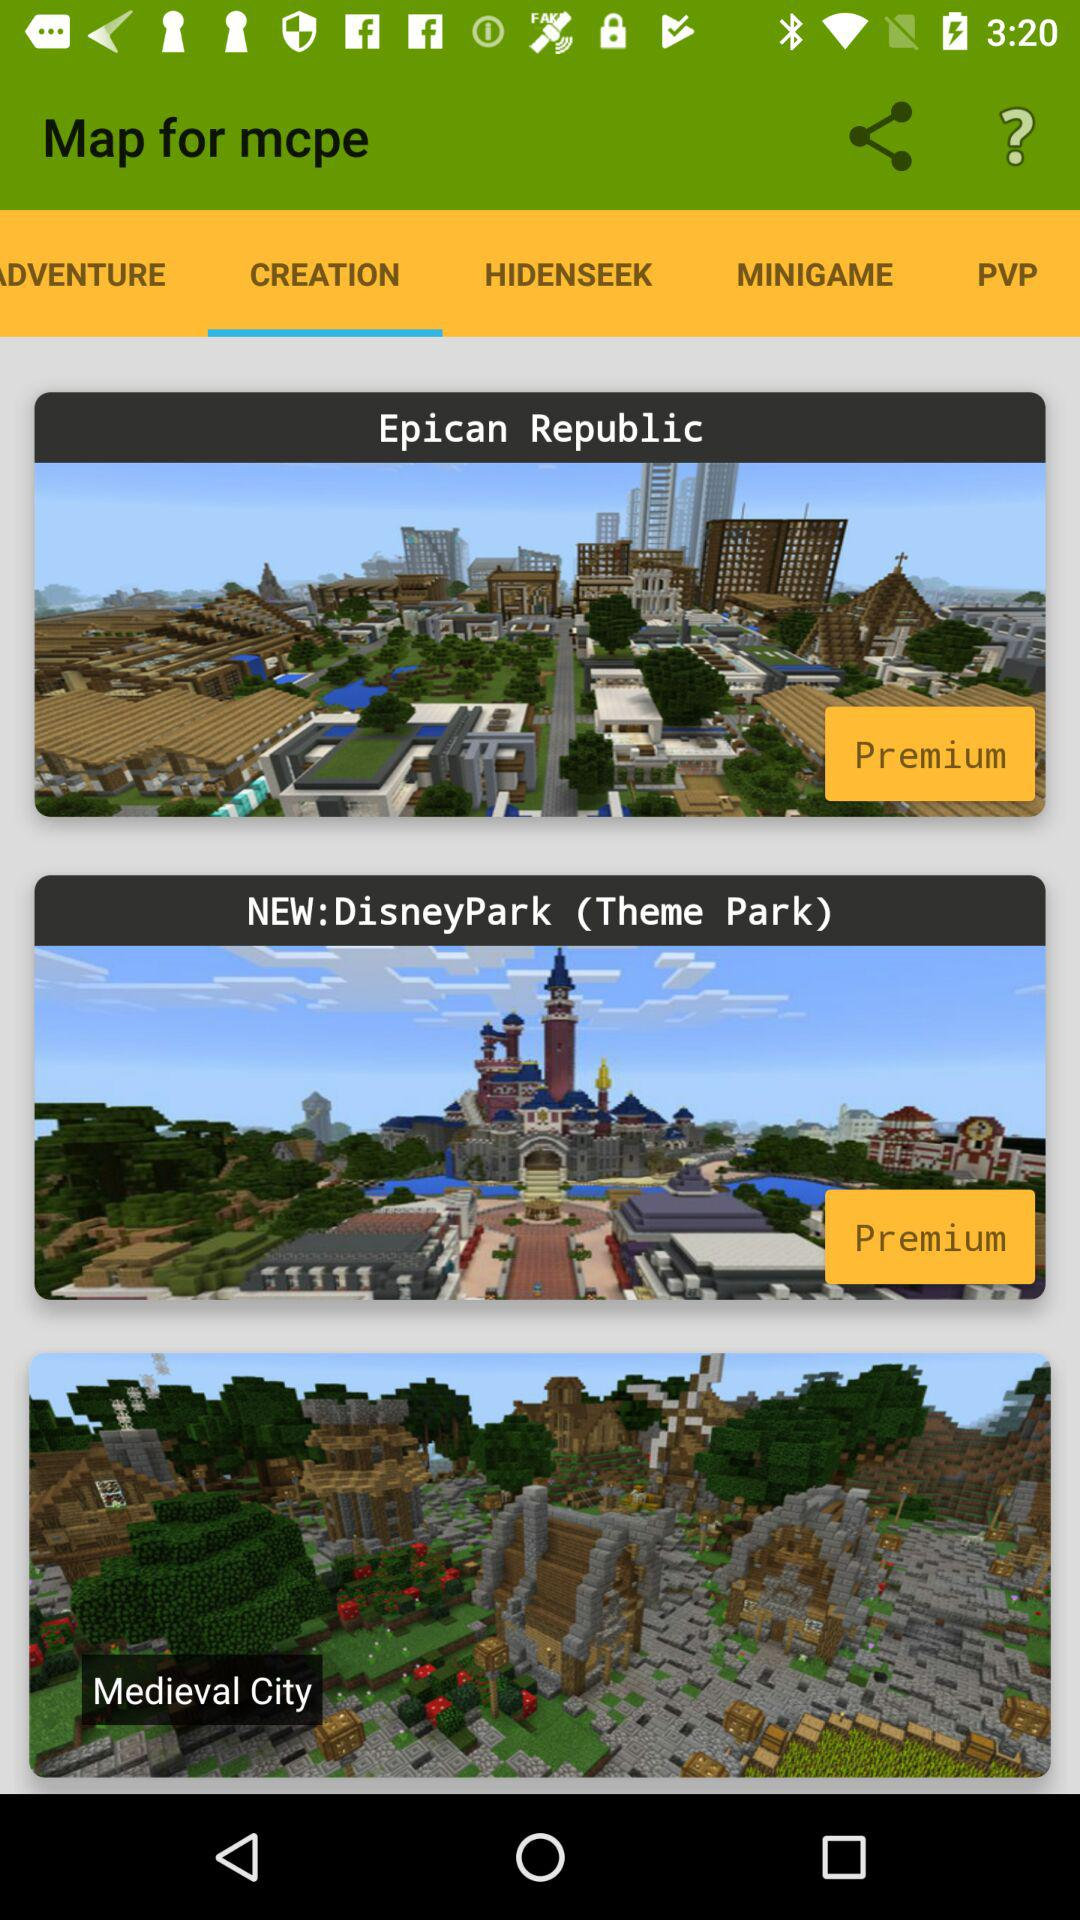How many maps are not premium?
Answer the question using a single word or phrase. 1 